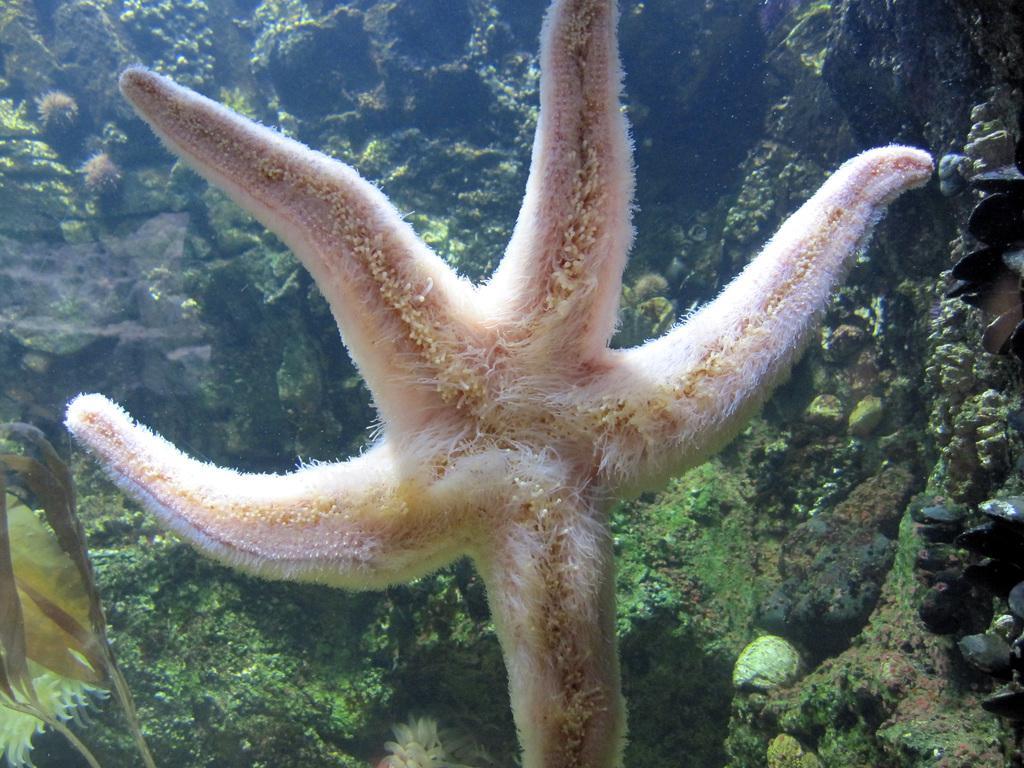Please provide a concise description of this image. In this image, in the middle, we can see a starfish. In the background, we can see some trees and plants. 